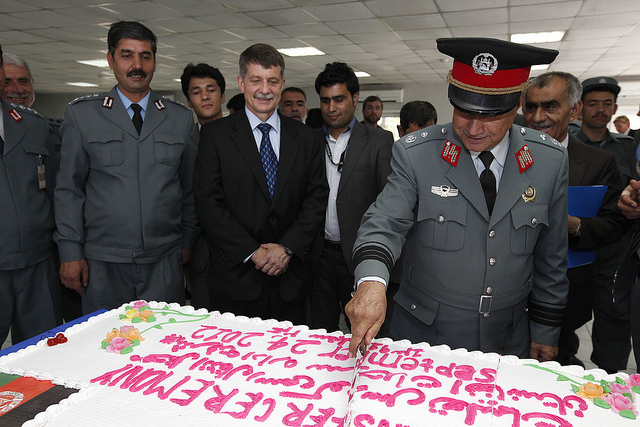Please extract the text content from this image. CEREMONY r 24 